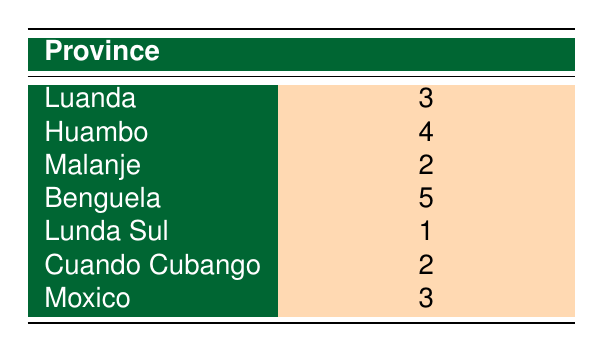What is the province with the highest number of festivals? By scanning the table, we see that the highest number of festivals is 5, which corresponds to Benguela.
Answer: Benguela How many festivals are held in Luanda? The table lists Luanda with 3 festivals.
Answer: 3 Is Lunda Sul hosting more festivals than Cuando Cubango? Lunda Sul has 1 festival, while Cuando Cubango has 2. Therefore, Lunda Sul is not hosting more festivals.
Answer: No What is the total number of festivals held across all provinces? To find the total, add the festivals from all provinces: 3 (Luanda) + 4 (Huambo) + 2 (Malanje) + 5 (Benguela) + 1 (Lunda Sul) + 2 (Cuando Cubango) + 3 (Moxico) = 20.
Answer: 20 Which provinces hold the same number of festivals? By examining the table, Luanda and Moxico both have 3 festivals, while Cuando Cubango and Malanje each have 2 festivals.
Answer: Luanda and Moxico, Cuando Cubango and Malanje What is the average number of festivals held per province? There are 7 provinces. The total number of festivals is 20, so the average is 20/7 = approximately 2.86.
Answer: 2.86 Are there any provinces with exactly 2 festivals? The table shows that Malanje and Cuando Cubango each have 2 festivals.
Answer: Yes What is the difference in the number of festivals between the province with the highest and the lowest counts? The highest is Benguela with 5 festivals and the lowest is Lunda Sul with 1 festival. The difference is 5 - 1 = 4.
Answer: 4 